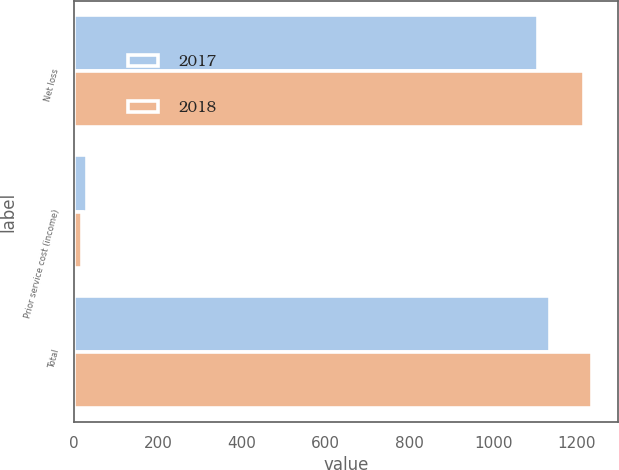<chart> <loc_0><loc_0><loc_500><loc_500><stacked_bar_chart><ecel><fcel>Net loss<fcel>Prior service cost (income)<fcel>Total<nl><fcel>2017<fcel>1106<fcel>30<fcel>1136<nl><fcel>2018<fcel>1217<fcel>19<fcel>1236<nl></chart> 